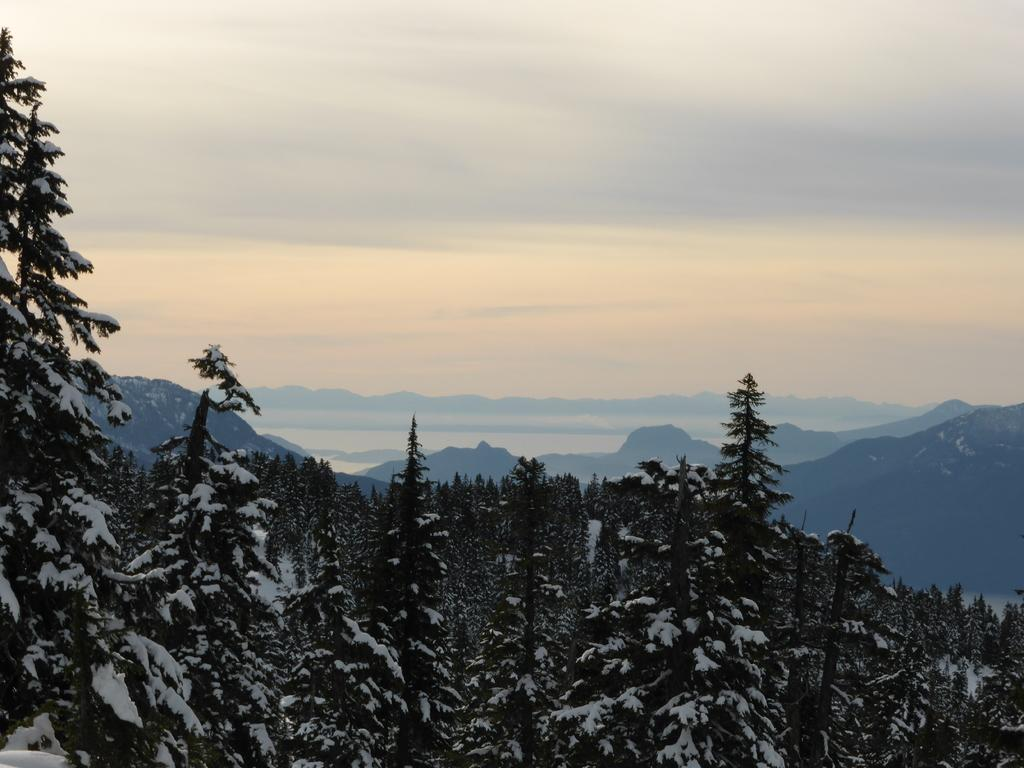What is the main feature of the image? The main feature of the image is trees covered with snow. What can be seen in the distance in the image? In the background of the image, there are mountains and trees. What type of straw is used to decorate the neck of the trees in the image? There is no straw or decoration mentioned in the image; it simply shows trees covered with snow. 